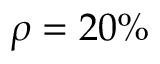<formula> <loc_0><loc_0><loc_500><loc_500>\rho = 2 0 \%</formula> 